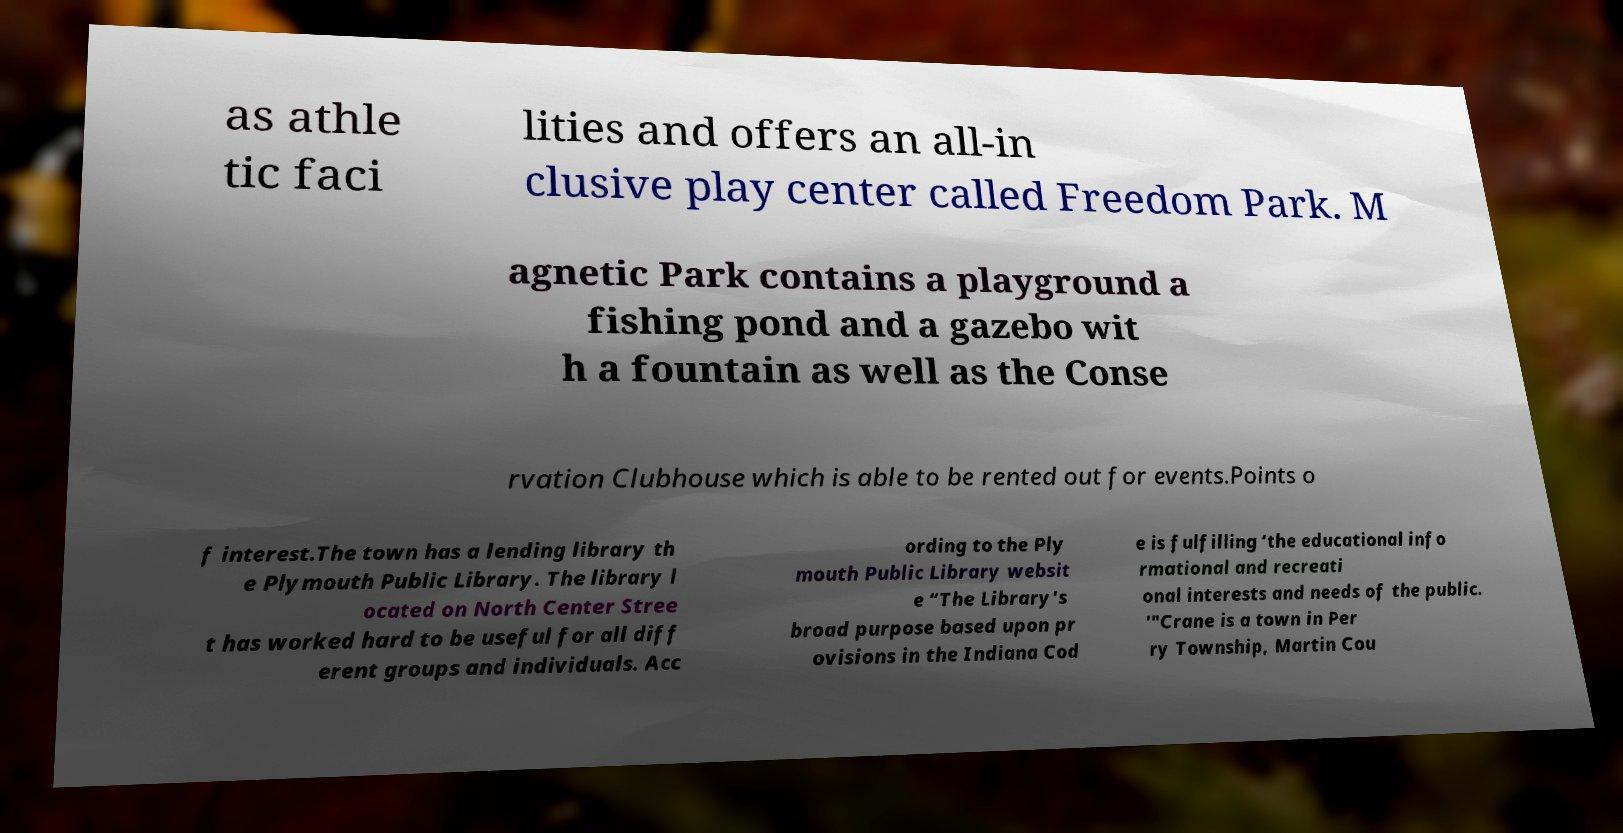Can you read and provide the text displayed in the image?This photo seems to have some interesting text. Can you extract and type it out for me? as athle tic faci lities and offers an all-in clusive play center called Freedom Park. M agnetic Park contains a playground a fishing pond and a gazebo wit h a fountain as well as the Conse rvation Clubhouse which is able to be rented out for events.Points o f interest.The town has a lending library th e Plymouth Public Library. The library l ocated on North Center Stree t has worked hard to be useful for all diff erent groups and individuals. Acc ording to the Ply mouth Public Library websit e “The Library's broad purpose based upon pr ovisions in the Indiana Cod e is fulfilling ‘the educational info rmational and recreati onal interests and needs of the public. '"Crane is a town in Per ry Township, Martin Cou 